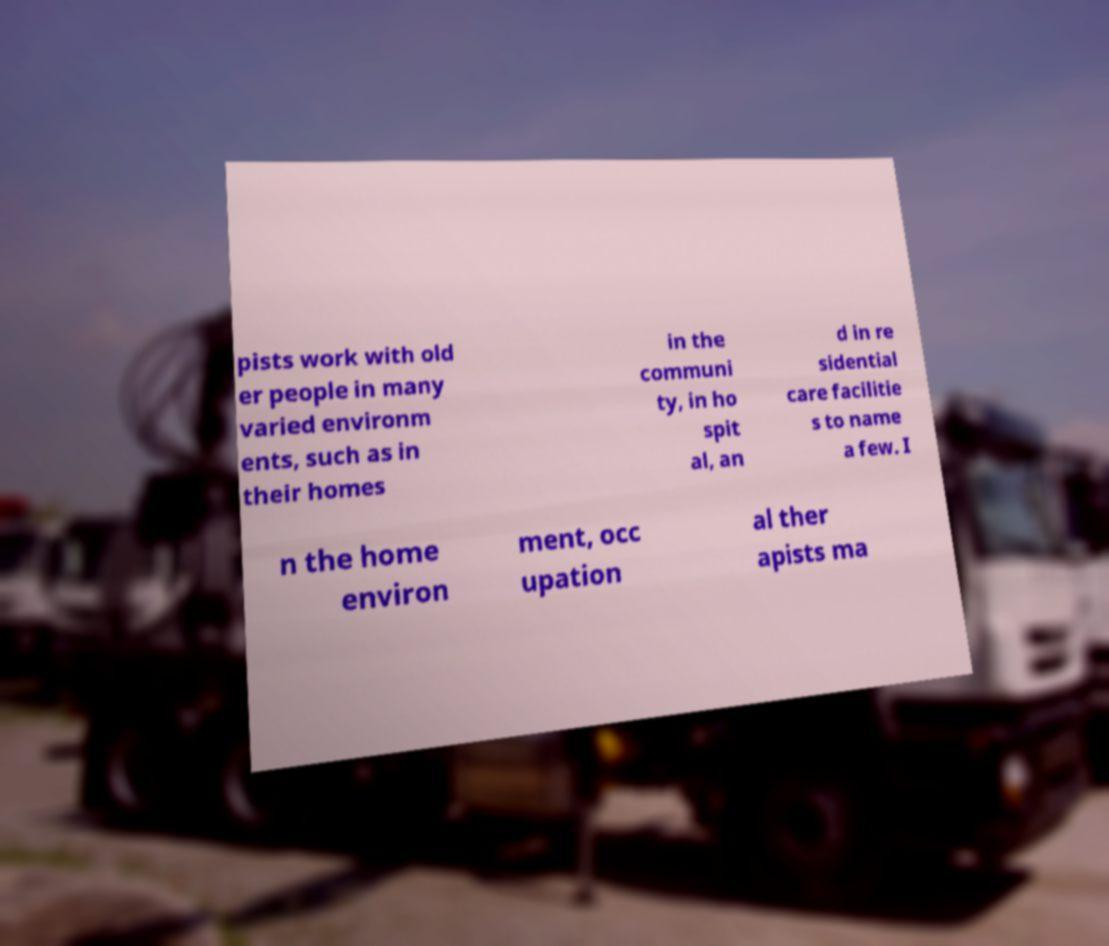Could you assist in decoding the text presented in this image and type it out clearly? pists work with old er people in many varied environm ents, such as in their homes in the communi ty, in ho spit al, an d in re sidential care facilitie s to name a few. I n the home environ ment, occ upation al ther apists ma 